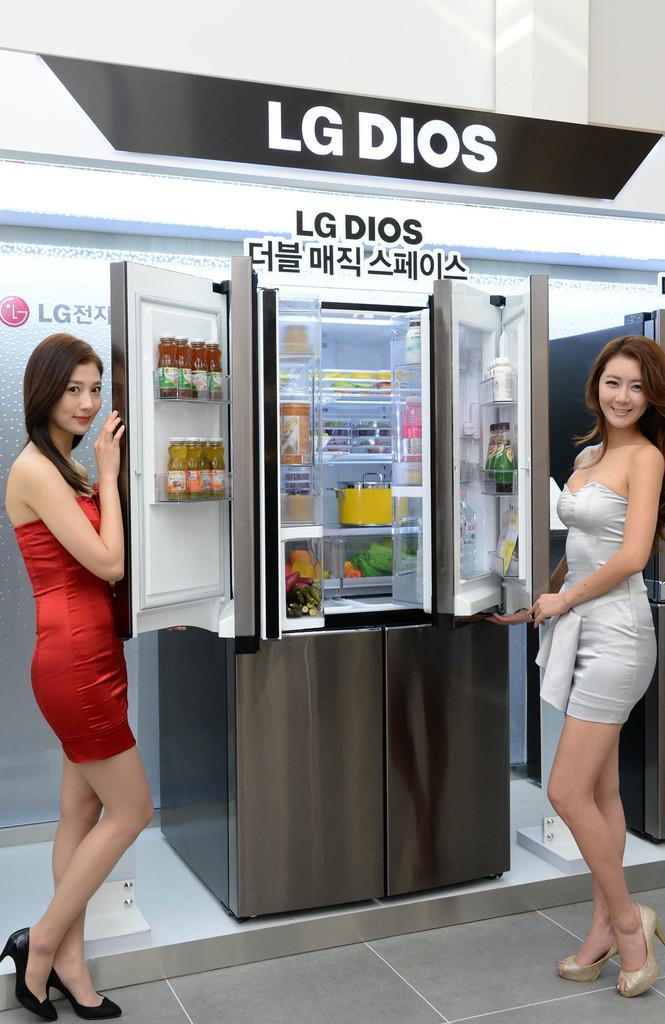<image>
Create a compact narrative representing the image presented. Two spokesmodels pose next to an LG DIOS appliance display. 